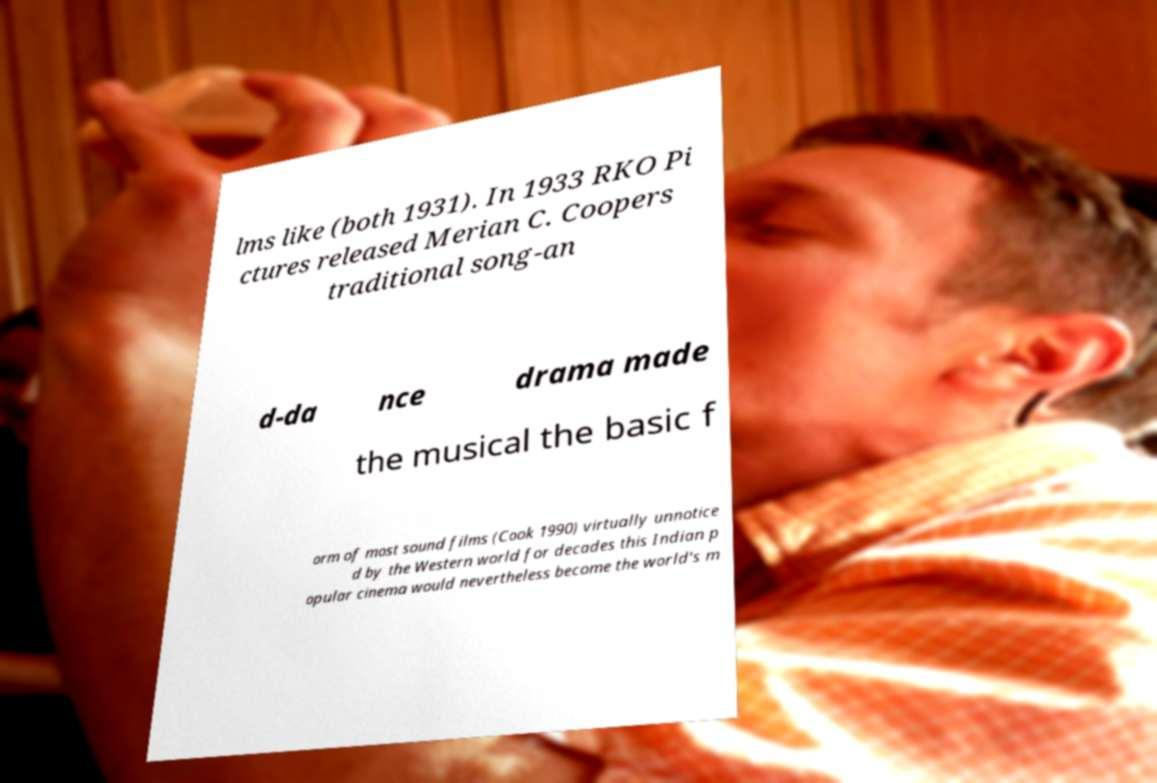What messages or text are displayed in this image? I need them in a readable, typed format. lms like (both 1931). In 1933 RKO Pi ctures released Merian C. Coopers traditional song-an d-da nce drama made the musical the basic f orm of most sound films (Cook 1990) virtually unnotice d by the Western world for decades this Indian p opular cinema would nevertheless become the world's m 